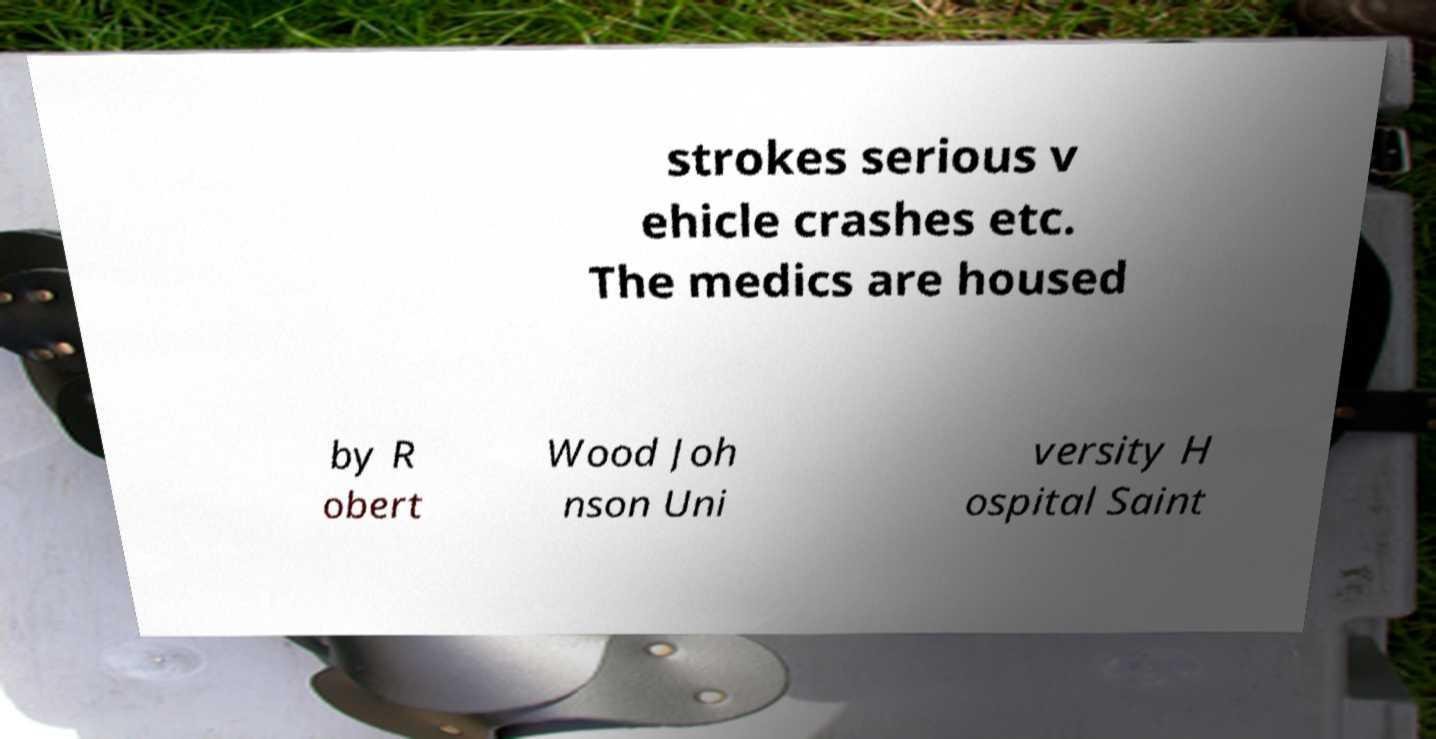For documentation purposes, I need the text within this image transcribed. Could you provide that? strokes serious v ehicle crashes etc. The medics are housed by R obert Wood Joh nson Uni versity H ospital Saint 